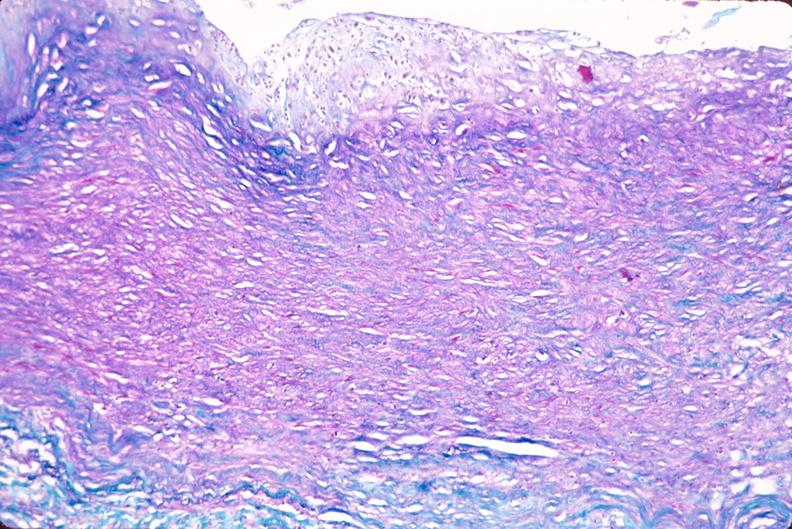s lesion present?
Answer the question using a single word or phrase. No 